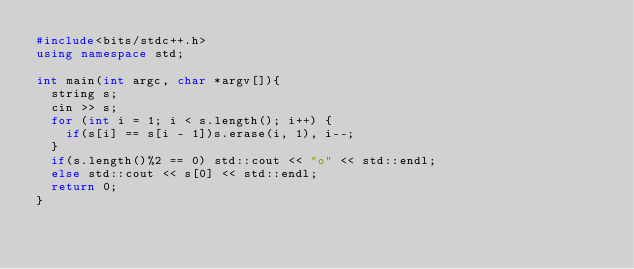<code> <loc_0><loc_0><loc_500><loc_500><_C++_>#include<bits/stdc++.h>
using namespace std;

int main(int argc, char *argv[]){
  string s;
  cin >> s;
  for (int i = 1; i < s.length(); i++) {
    if(s[i] == s[i - 1])s.erase(i, 1), i--;
  }
  if(s.length()%2 == 0) std::cout << "o" << std::endl;
  else std::cout << s[0] << std::endl;
  return 0;
}</code> 